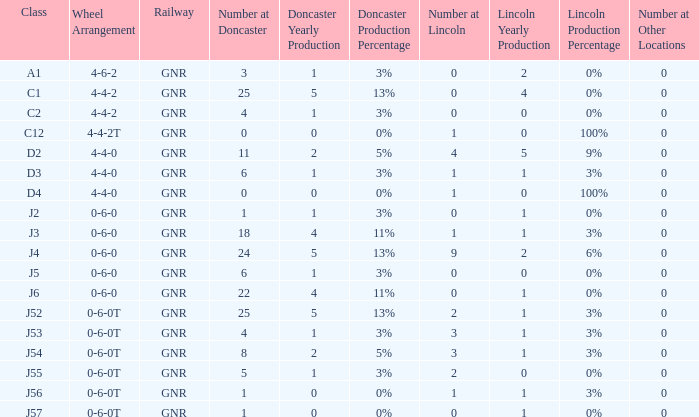Which Class has a Number at Lincoln larger than 0 and a Number at Doncaster of 8? J54. 